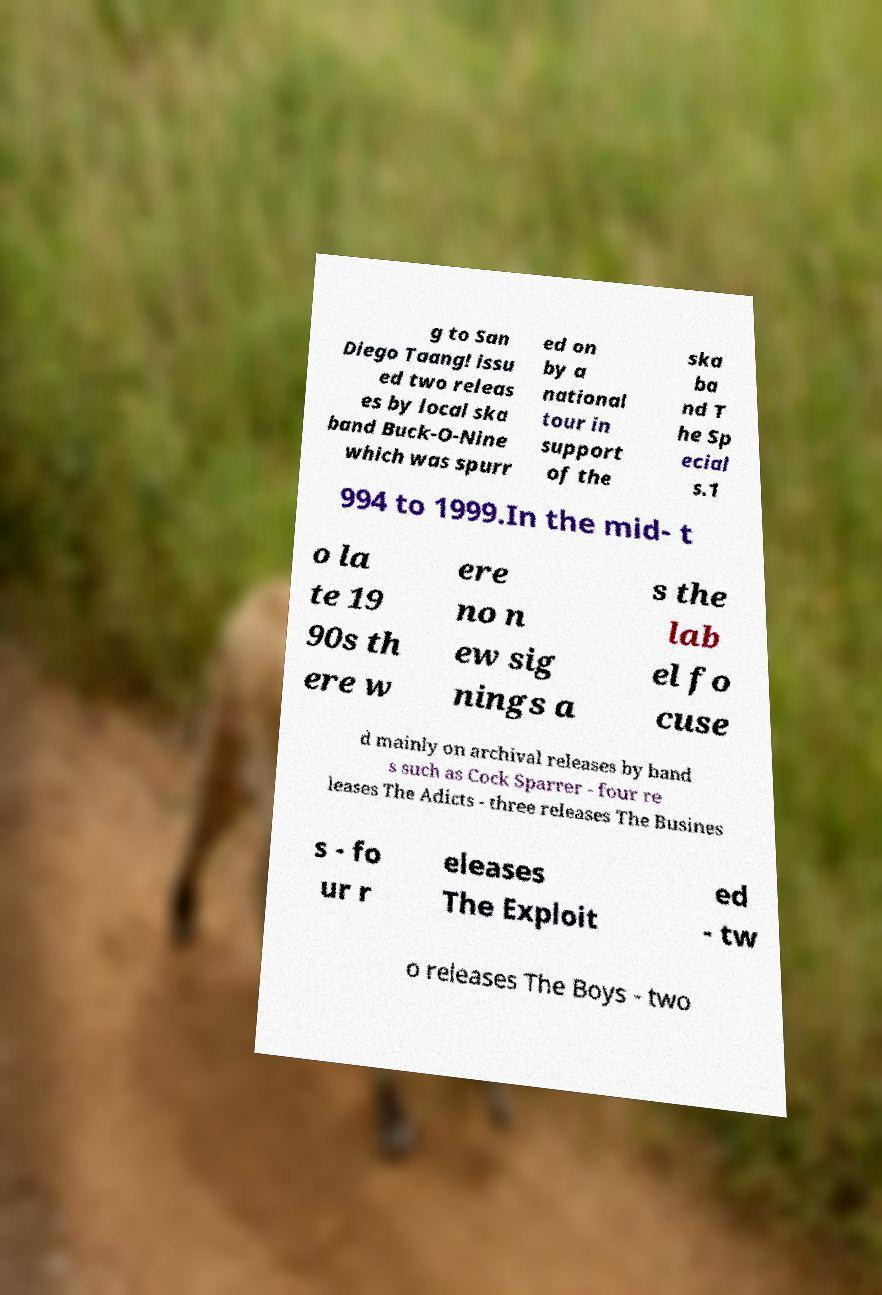Could you assist in decoding the text presented in this image and type it out clearly? g to San Diego Taang! issu ed two releas es by local ska band Buck-O-Nine which was spurr ed on by a national tour in support of the ska ba nd T he Sp ecial s.1 994 to 1999.In the mid- t o la te 19 90s th ere w ere no n ew sig nings a s the lab el fo cuse d mainly on archival releases by band s such as Cock Sparrer - four re leases The Adicts - three releases The Busines s - fo ur r eleases The Exploit ed - tw o releases The Boys - two 